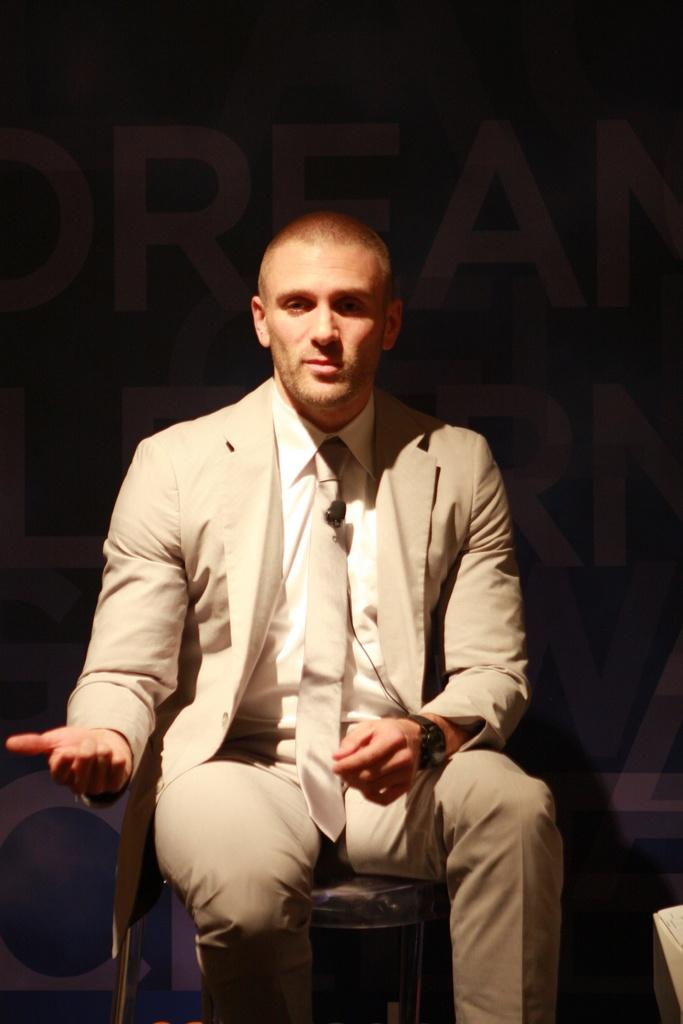What is the main subject in the foreground of the image? There is a person sitting in the foreground of the image. What is the person wearing? The person is wearing a suit. Can you describe any text that is visible in the image? Yes, there is text in the image. What is the color of the background in the image? The background of the image is dark. How many babies are crawling on the person's suit in the image? There are no babies present in the image, and therefore no babies crawling on the person's suit. What type of spiders can be seen weaving a web in the background of the image? There are no spiders or webs visible in the image; the background is dark. 